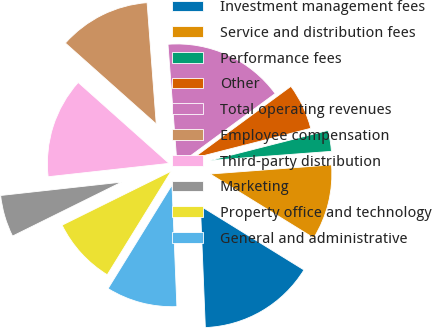Convert chart to OTSL. <chart><loc_0><loc_0><loc_500><loc_500><pie_chart><fcel>Investment management fees<fcel>Service and distribution fees<fcel>Performance fees<fcel>Other<fcel>Total operating revenues<fcel>Employee compensation<fcel>Third-party distribution<fcel>Marketing<fcel>Property office and technology<fcel>General and administrative<nl><fcel>15.55%<fcel>10.0%<fcel>2.78%<fcel>6.11%<fcel>16.11%<fcel>12.22%<fcel>13.33%<fcel>5.56%<fcel>8.89%<fcel>9.44%<nl></chart> 